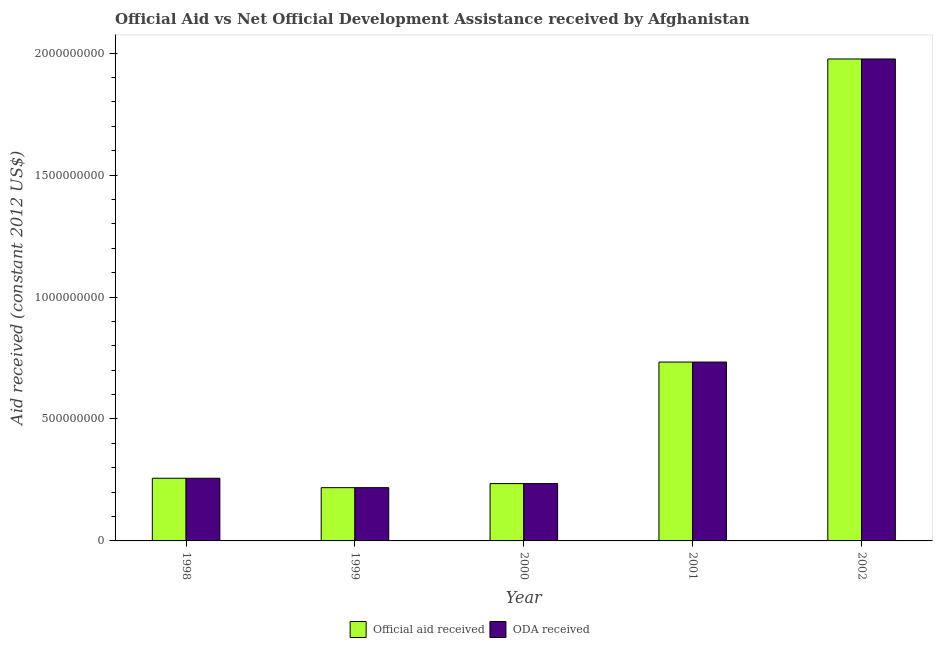How many groups of bars are there?
Your answer should be compact. 5. Are the number of bars per tick equal to the number of legend labels?
Offer a very short reply. Yes. Are the number of bars on each tick of the X-axis equal?
Your answer should be very brief. Yes. How many bars are there on the 1st tick from the left?
Provide a succinct answer. 2. What is the label of the 1st group of bars from the left?
Your answer should be compact. 1998. In how many cases, is the number of bars for a given year not equal to the number of legend labels?
Ensure brevity in your answer.  0. What is the oda received in 1999?
Make the answer very short. 2.18e+08. Across all years, what is the maximum oda received?
Provide a succinct answer. 1.98e+09. Across all years, what is the minimum oda received?
Your answer should be very brief. 2.18e+08. In which year was the oda received minimum?
Your answer should be compact. 1999. What is the total official aid received in the graph?
Your answer should be very brief. 3.42e+09. What is the difference between the oda received in 2001 and that in 2002?
Keep it short and to the point. -1.24e+09. What is the difference between the oda received in 2001 and the official aid received in 2002?
Ensure brevity in your answer.  -1.24e+09. What is the average oda received per year?
Provide a short and direct response. 6.84e+08. In the year 2001, what is the difference between the oda received and official aid received?
Your response must be concise. 0. What is the ratio of the oda received in 1999 to that in 2001?
Offer a terse response. 0.3. Is the official aid received in 1999 less than that in 2000?
Offer a terse response. Yes. What is the difference between the highest and the second highest oda received?
Offer a terse response. 1.24e+09. What is the difference between the highest and the lowest official aid received?
Your answer should be compact. 1.76e+09. In how many years, is the oda received greater than the average oda received taken over all years?
Make the answer very short. 2. What does the 2nd bar from the left in 1999 represents?
Give a very brief answer. ODA received. What does the 2nd bar from the right in 1999 represents?
Give a very brief answer. Official aid received. How many bars are there?
Provide a short and direct response. 10. Are all the bars in the graph horizontal?
Give a very brief answer. No. What is the difference between two consecutive major ticks on the Y-axis?
Provide a succinct answer. 5.00e+08. Are the values on the major ticks of Y-axis written in scientific E-notation?
Make the answer very short. No. Does the graph contain any zero values?
Offer a very short reply. No. How many legend labels are there?
Give a very brief answer. 2. What is the title of the graph?
Offer a terse response. Official Aid vs Net Official Development Assistance received by Afghanistan . What is the label or title of the Y-axis?
Offer a very short reply. Aid received (constant 2012 US$). What is the Aid received (constant 2012 US$) of Official aid received in 1998?
Provide a short and direct response. 2.57e+08. What is the Aid received (constant 2012 US$) in ODA received in 1998?
Offer a very short reply. 2.57e+08. What is the Aid received (constant 2012 US$) in Official aid received in 1999?
Your answer should be compact. 2.18e+08. What is the Aid received (constant 2012 US$) in ODA received in 1999?
Provide a succinct answer. 2.18e+08. What is the Aid received (constant 2012 US$) in Official aid received in 2000?
Keep it short and to the point. 2.35e+08. What is the Aid received (constant 2012 US$) in ODA received in 2000?
Offer a very short reply. 2.35e+08. What is the Aid received (constant 2012 US$) in Official aid received in 2001?
Provide a succinct answer. 7.33e+08. What is the Aid received (constant 2012 US$) in ODA received in 2001?
Provide a short and direct response. 7.33e+08. What is the Aid received (constant 2012 US$) in Official aid received in 2002?
Give a very brief answer. 1.98e+09. What is the Aid received (constant 2012 US$) of ODA received in 2002?
Ensure brevity in your answer.  1.98e+09. Across all years, what is the maximum Aid received (constant 2012 US$) in Official aid received?
Your response must be concise. 1.98e+09. Across all years, what is the maximum Aid received (constant 2012 US$) of ODA received?
Your response must be concise. 1.98e+09. Across all years, what is the minimum Aid received (constant 2012 US$) in Official aid received?
Make the answer very short. 2.18e+08. Across all years, what is the minimum Aid received (constant 2012 US$) of ODA received?
Ensure brevity in your answer.  2.18e+08. What is the total Aid received (constant 2012 US$) in Official aid received in the graph?
Provide a short and direct response. 3.42e+09. What is the total Aid received (constant 2012 US$) in ODA received in the graph?
Your response must be concise. 3.42e+09. What is the difference between the Aid received (constant 2012 US$) of Official aid received in 1998 and that in 1999?
Make the answer very short. 3.85e+07. What is the difference between the Aid received (constant 2012 US$) in ODA received in 1998 and that in 1999?
Ensure brevity in your answer.  3.85e+07. What is the difference between the Aid received (constant 2012 US$) of Official aid received in 1998 and that in 2000?
Your answer should be very brief. 2.19e+07. What is the difference between the Aid received (constant 2012 US$) of ODA received in 1998 and that in 2000?
Offer a very short reply. 2.19e+07. What is the difference between the Aid received (constant 2012 US$) in Official aid received in 1998 and that in 2001?
Your answer should be very brief. -4.76e+08. What is the difference between the Aid received (constant 2012 US$) of ODA received in 1998 and that in 2001?
Offer a very short reply. -4.76e+08. What is the difference between the Aid received (constant 2012 US$) of Official aid received in 1998 and that in 2002?
Offer a terse response. -1.72e+09. What is the difference between the Aid received (constant 2012 US$) of ODA received in 1998 and that in 2002?
Offer a very short reply. -1.72e+09. What is the difference between the Aid received (constant 2012 US$) in Official aid received in 1999 and that in 2000?
Your response must be concise. -1.66e+07. What is the difference between the Aid received (constant 2012 US$) of ODA received in 1999 and that in 2000?
Your answer should be compact. -1.66e+07. What is the difference between the Aid received (constant 2012 US$) in Official aid received in 1999 and that in 2001?
Provide a short and direct response. -5.15e+08. What is the difference between the Aid received (constant 2012 US$) in ODA received in 1999 and that in 2001?
Offer a very short reply. -5.15e+08. What is the difference between the Aid received (constant 2012 US$) of Official aid received in 1999 and that in 2002?
Keep it short and to the point. -1.76e+09. What is the difference between the Aid received (constant 2012 US$) of ODA received in 1999 and that in 2002?
Keep it short and to the point. -1.76e+09. What is the difference between the Aid received (constant 2012 US$) in Official aid received in 2000 and that in 2001?
Keep it short and to the point. -4.98e+08. What is the difference between the Aid received (constant 2012 US$) in ODA received in 2000 and that in 2001?
Offer a terse response. -4.98e+08. What is the difference between the Aid received (constant 2012 US$) of Official aid received in 2000 and that in 2002?
Offer a terse response. -1.74e+09. What is the difference between the Aid received (constant 2012 US$) in ODA received in 2000 and that in 2002?
Give a very brief answer. -1.74e+09. What is the difference between the Aid received (constant 2012 US$) in Official aid received in 2001 and that in 2002?
Provide a succinct answer. -1.24e+09. What is the difference between the Aid received (constant 2012 US$) in ODA received in 2001 and that in 2002?
Your answer should be compact. -1.24e+09. What is the difference between the Aid received (constant 2012 US$) in Official aid received in 1998 and the Aid received (constant 2012 US$) in ODA received in 1999?
Your response must be concise. 3.85e+07. What is the difference between the Aid received (constant 2012 US$) of Official aid received in 1998 and the Aid received (constant 2012 US$) of ODA received in 2000?
Give a very brief answer. 2.19e+07. What is the difference between the Aid received (constant 2012 US$) in Official aid received in 1998 and the Aid received (constant 2012 US$) in ODA received in 2001?
Your answer should be very brief. -4.76e+08. What is the difference between the Aid received (constant 2012 US$) of Official aid received in 1998 and the Aid received (constant 2012 US$) of ODA received in 2002?
Your answer should be very brief. -1.72e+09. What is the difference between the Aid received (constant 2012 US$) in Official aid received in 1999 and the Aid received (constant 2012 US$) in ODA received in 2000?
Make the answer very short. -1.66e+07. What is the difference between the Aid received (constant 2012 US$) of Official aid received in 1999 and the Aid received (constant 2012 US$) of ODA received in 2001?
Your answer should be very brief. -5.15e+08. What is the difference between the Aid received (constant 2012 US$) in Official aid received in 1999 and the Aid received (constant 2012 US$) in ODA received in 2002?
Give a very brief answer. -1.76e+09. What is the difference between the Aid received (constant 2012 US$) of Official aid received in 2000 and the Aid received (constant 2012 US$) of ODA received in 2001?
Offer a very short reply. -4.98e+08. What is the difference between the Aid received (constant 2012 US$) in Official aid received in 2000 and the Aid received (constant 2012 US$) in ODA received in 2002?
Offer a very short reply. -1.74e+09. What is the difference between the Aid received (constant 2012 US$) in Official aid received in 2001 and the Aid received (constant 2012 US$) in ODA received in 2002?
Offer a terse response. -1.24e+09. What is the average Aid received (constant 2012 US$) in Official aid received per year?
Provide a succinct answer. 6.84e+08. What is the average Aid received (constant 2012 US$) of ODA received per year?
Make the answer very short. 6.84e+08. In the year 1999, what is the difference between the Aid received (constant 2012 US$) of Official aid received and Aid received (constant 2012 US$) of ODA received?
Provide a short and direct response. 0. In the year 2002, what is the difference between the Aid received (constant 2012 US$) of Official aid received and Aid received (constant 2012 US$) of ODA received?
Ensure brevity in your answer.  0. What is the ratio of the Aid received (constant 2012 US$) in Official aid received in 1998 to that in 1999?
Your answer should be compact. 1.18. What is the ratio of the Aid received (constant 2012 US$) in ODA received in 1998 to that in 1999?
Provide a succinct answer. 1.18. What is the ratio of the Aid received (constant 2012 US$) in Official aid received in 1998 to that in 2000?
Your answer should be compact. 1.09. What is the ratio of the Aid received (constant 2012 US$) in ODA received in 1998 to that in 2000?
Ensure brevity in your answer.  1.09. What is the ratio of the Aid received (constant 2012 US$) of Official aid received in 1998 to that in 2001?
Offer a terse response. 0.35. What is the ratio of the Aid received (constant 2012 US$) in ODA received in 1998 to that in 2001?
Your answer should be compact. 0.35. What is the ratio of the Aid received (constant 2012 US$) in Official aid received in 1998 to that in 2002?
Provide a succinct answer. 0.13. What is the ratio of the Aid received (constant 2012 US$) of ODA received in 1998 to that in 2002?
Offer a very short reply. 0.13. What is the ratio of the Aid received (constant 2012 US$) of Official aid received in 1999 to that in 2000?
Provide a short and direct response. 0.93. What is the ratio of the Aid received (constant 2012 US$) in ODA received in 1999 to that in 2000?
Offer a very short reply. 0.93. What is the ratio of the Aid received (constant 2012 US$) of Official aid received in 1999 to that in 2001?
Keep it short and to the point. 0.3. What is the ratio of the Aid received (constant 2012 US$) of ODA received in 1999 to that in 2001?
Offer a very short reply. 0.3. What is the ratio of the Aid received (constant 2012 US$) of Official aid received in 1999 to that in 2002?
Keep it short and to the point. 0.11. What is the ratio of the Aid received (constant 2012 US$) in ODA received in 1999 to that in 2002?
Give a very brief answer. 0.11. What is the ratio of the Aid received (constant 2012 US$) of Official aid received in 2000 to that in 2001?
Ensure brevity in your answer.  0.32. What is the ratio of the Aid received (constant 2012 US$) of ODA received in 2000 to that in 2001?
Give a very brief answer. 0.32. What is the ratio of the Aid received (constant 2012 US$) of Official aid received in 2000 to that in 2002?
Make the answer very short. 0.12. What is the ratio of the Aid received (constant 2012 US$) in ODA received in 2000 to that in 2002?
Offer a terse response. 0.12. What is the ratio of the Aid received (constant 2012 US$) in Official aid received in 2001 to that in 2002?
Provide a short and direct response. 0.37. What is the ratio of the Aid received (constant 2012 US$) of ODA received in 2001 to that in 2002?
Your response must be concise. 0.37. What is the difference between the highest and the second highest Aid received (constant 2012 US$) of Official aid received?
Ensure brevity in your answer.  1.24e+09. What is the difference between the highest and the second highest Aid received (constant 2012 US$) in ODA received?
Your answer should be very brief. 1.24e+09. What is the difference between the highest and the lowest Aid received (constant 2012 US$) in Official aid received?
Ensure brevity in your answer.  1.76e+09. What is the difference between the highest and the lowest Aid received (constant 2012 US$) of ODA received?
Offer a terse response. 1.76e+09. 